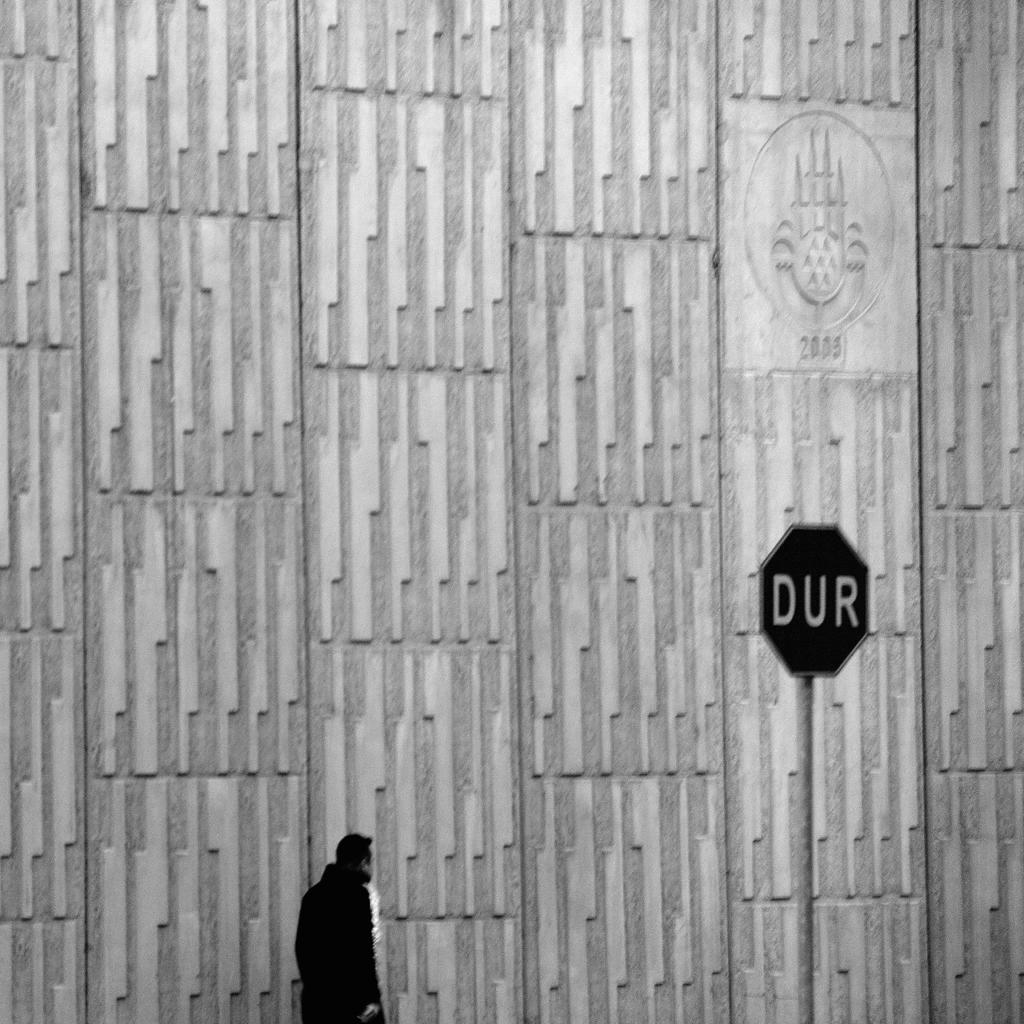What is the color scheme of the image? The image is black and white. What can be seen on the wall in the image? There is a logo on the wall. Who or what is present at the bottom of the image? There is a person at the bottom of the image. What is attached to the pole in the image? There is a sign board on the pole. Where is the dock located in the image? There is no dock present in the image. What type of meeting is taking place in the image? There is no meeting taking place in the image. 